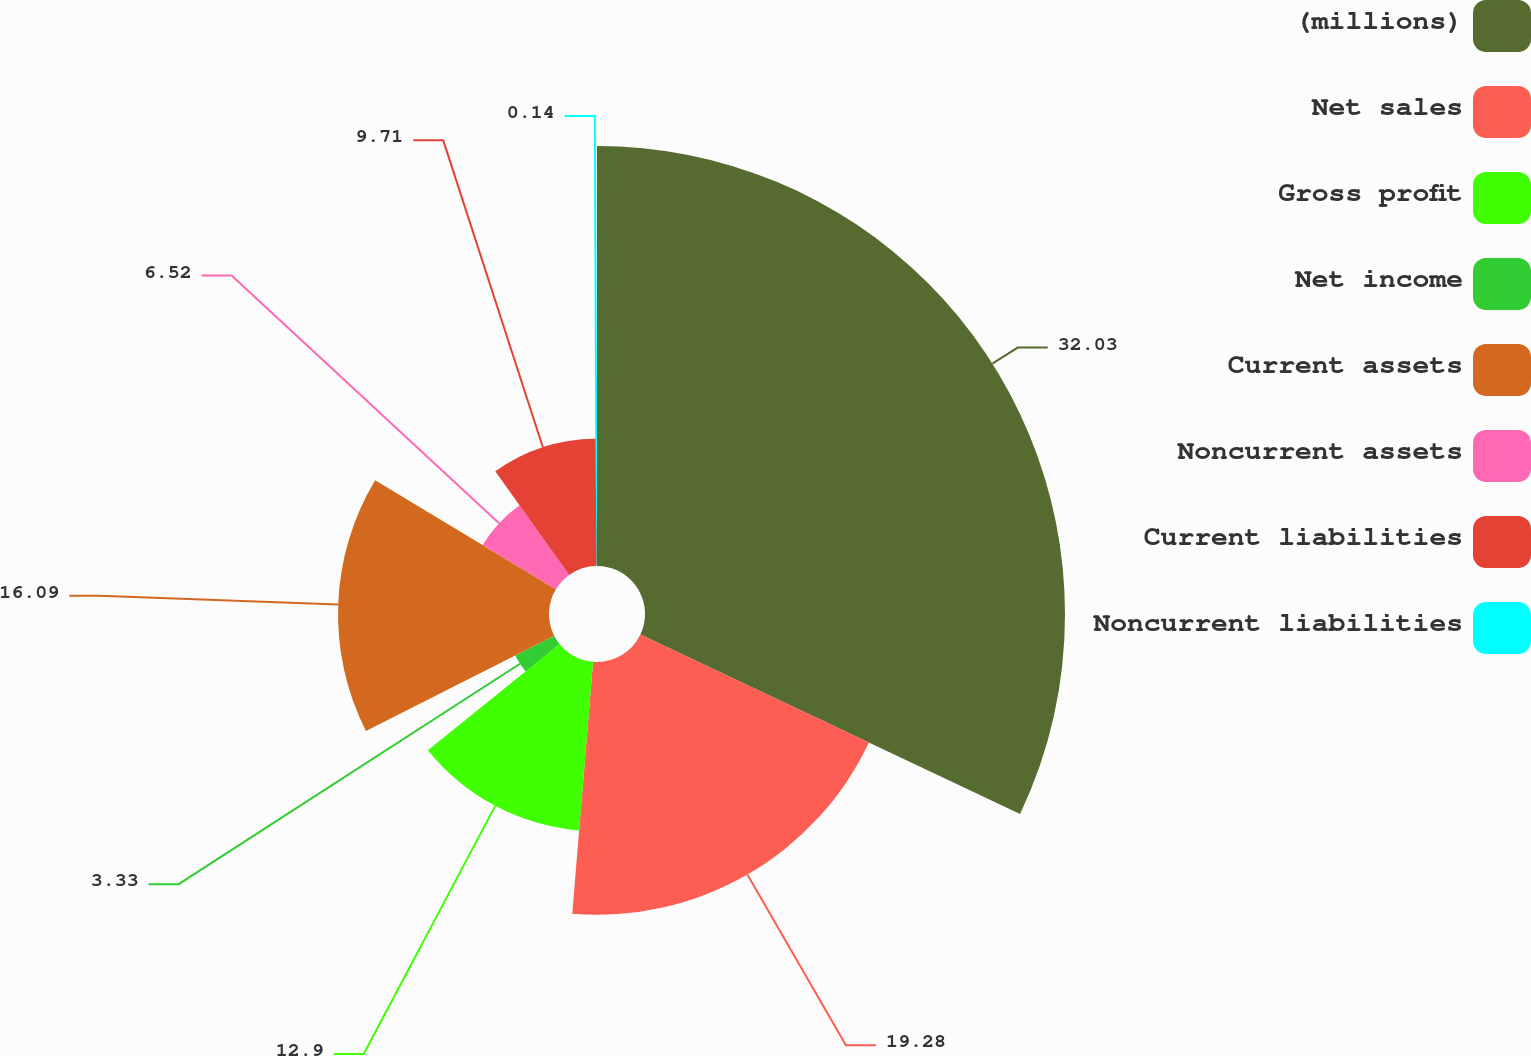Convert chart. <chart><loc_0><loc_0><loc_500><loc_500><pie_chart><fcel>(millions)<fcel>Net sales<fcel>Gross profit<fcel>Net income<fcel>Current assets<fcel>Noncurrent assets<fcel>Current liabilities<fcel>Noncurrent liabilities<nl><fcel>32.03%<fcel>19.28%<fcel>12.9%<fcel>3.33%<fcel>16.09%<fcel>6.52%<fcel>9.71%<fcel>0.14%<nl></chart> 